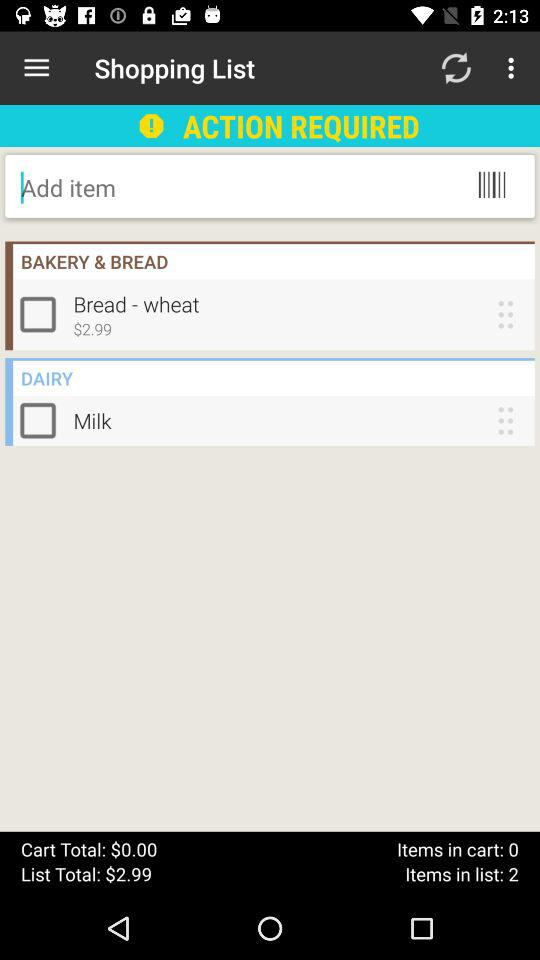What is the currency of the price? The currency of the price is dollars. 